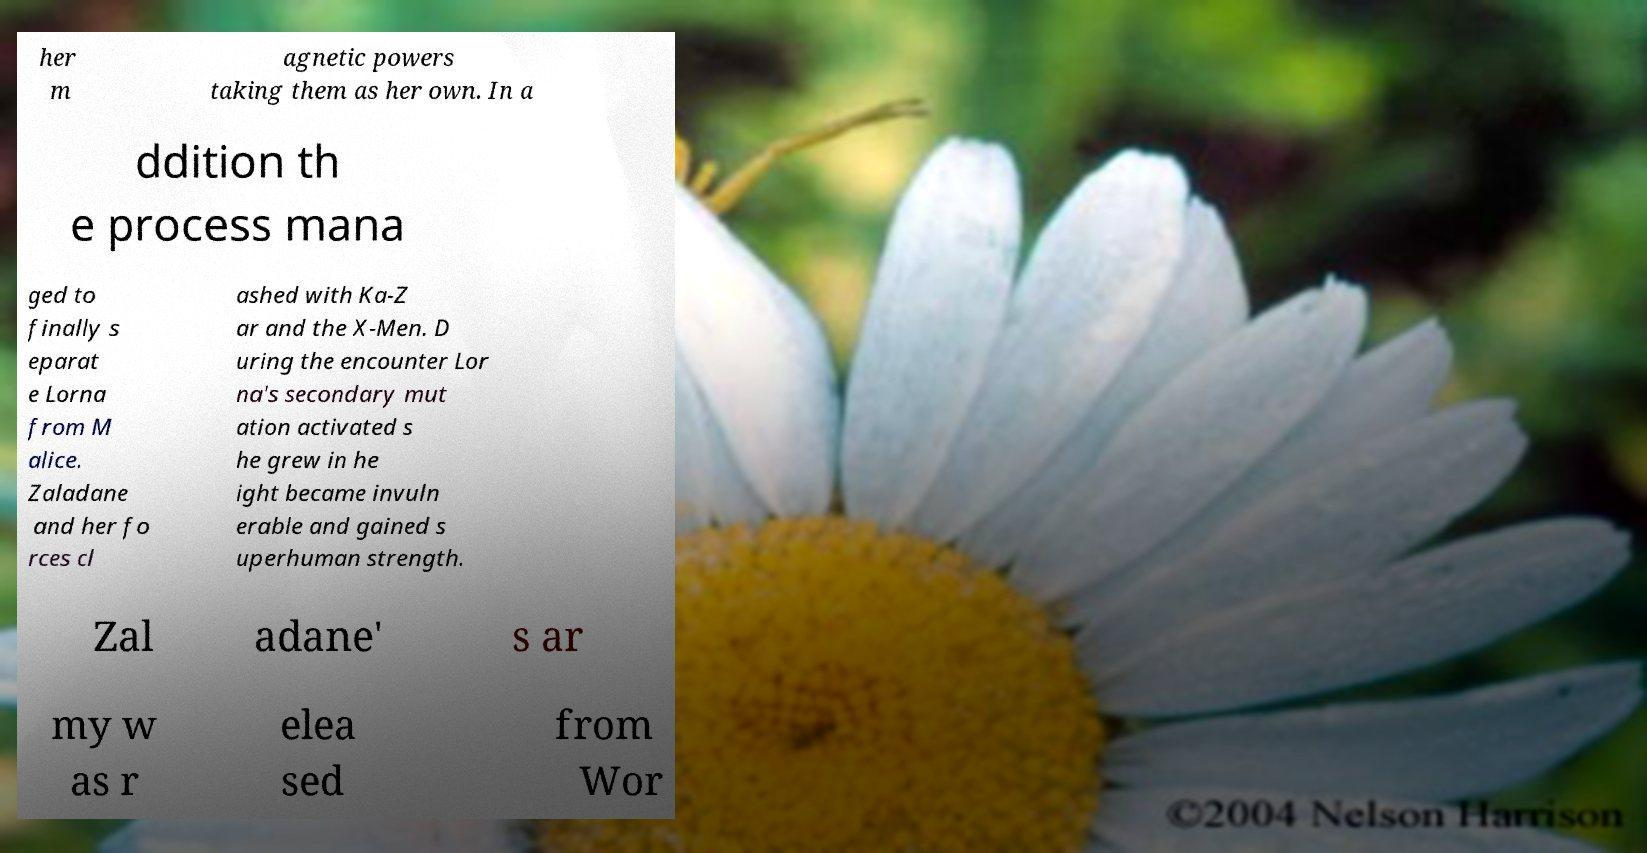Could you extract and type out the text from this image? her m agnetic powers taking them as her own. In a ddition th e process mana ged to finally s eparat e Lorna from M alice. Zaladane and her fo rces cl ashed with Ka-Z ar and the X-Men. D uring the encounter Lor na's secondary mut ation activated s he grew in he ight became invuln erable and gained s uperhuman strength. Zal adane' s ar my w as r elea sed from Wor 